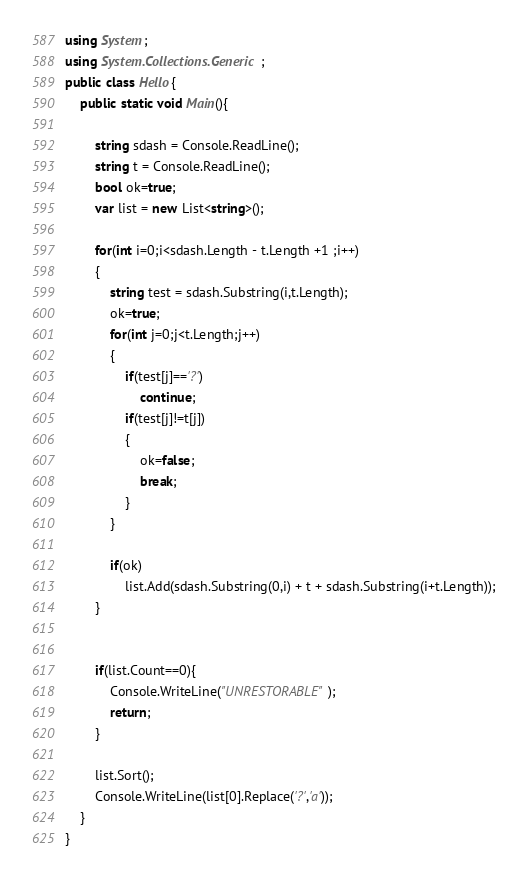<code> <loc_0><loc_0><loc_500><loc_500><_C#_>using System;
using System.Collections.Generic;
public class Hello{
    public static void Main(){
        
        string sdash = Console.ReadLine();
        string t = Console.ReadLine();
        bool ok=true;
        var list = new List<string>();
        
        for(int i=0;i<sdash.Length - t.Length +1 ;i++)
        {
            string test = sdash.Substring(i,t.Length);
            ok=true;
            for(int j=0;j<t.Length;j++)
            {
                if(test[j]=='?')
                    continue;
                if(test[j]!=t[j])
                {
                    ok=false;
                    break;
                }
            }
            
            if(ok)
                list.Add(sdash.Substring(0,i) + t + sdash.Substring(i+t.Length));
        }
        
        
        if(list.Count==0){
            Console.WriteLine("UNRESTORABLE");
            return;
        }
        
        list.Sort();
        Console.WriteLine(list[0].Replace('?','a'));
    }
}
</code> 